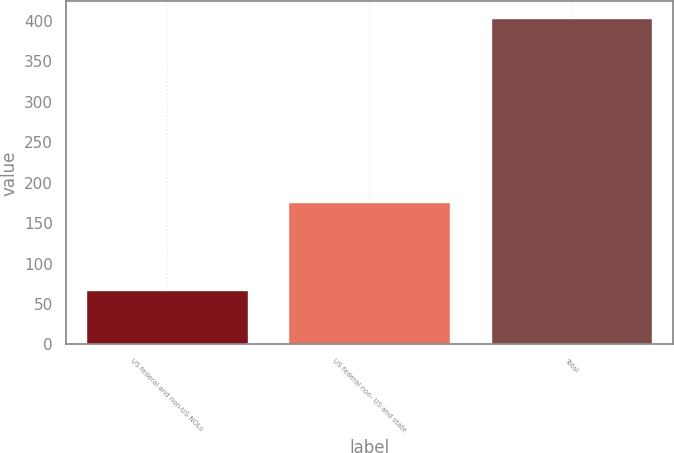Convert chart. <chart><loc_0><loc_0><loc_500><loc_500><bar_chart><fcel>US federal and non-US NOLs<fcel>US federal non- US and state<fcel>Total<nl><fcel>67<fcel>176<fcel>404<nl></chart> 